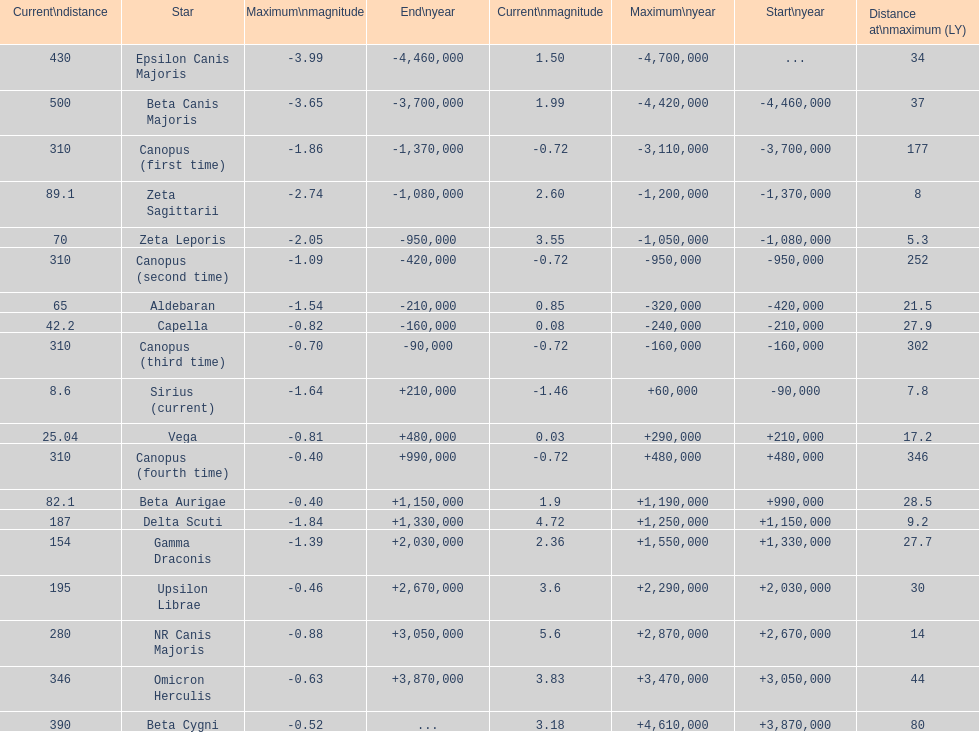What is the number of stars that have a maximum magnitude less than zero? 5. 